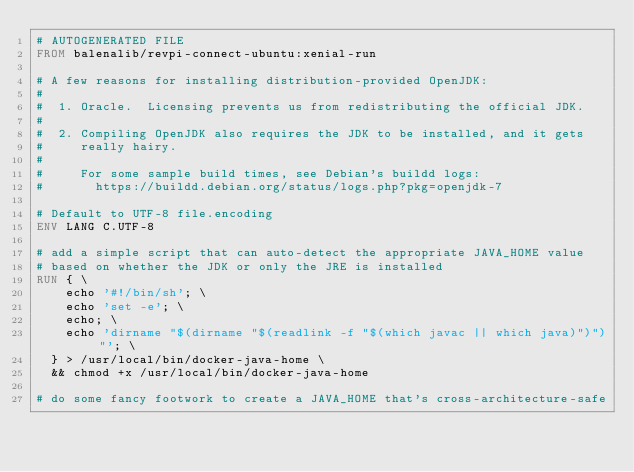<code> <loc_0><loc_0><loc_500><loc_500><_Dockerfile_># AUTOGENERATED FILE
FROM balenalib/revpi-connect-ubuntu:xenial-run

# A few reasons for installing distribution-provided OpenJDK:
#
#  1. Oracle.  Licensing prevents us from redistributing the official JDK.
#
#  2. Compiling OpenJDK also requires the JDK to be installed, and it gets
#     really hairy.
#
#     For some sample build times, see Debian's buildd logs:
#       https://buildd.debian.org/status/logs.php?pkg=openjdk-7

# Default to UTF-8 file.encoding
ENV LANG C.UTF-8

# add a simple script that can auto-detect the appropriate JAVA_HOME value
# based on whether the JDK or only the JRE is installed
RUN { \
		echo '#!/bin/sh'; \
		echo 'set -e'; \
		echo; \
		echo 'dirname "$(dirname "$(readlink -f "$(which javac || which java)")")"'; \
	} > /usr/local/bin/docker-java-home \
	&& chmod +x /usr/local/bin/docker-java-home

# do some fancy footwork to create a JAVA_HOME that's cross-architecture-safe</code> 